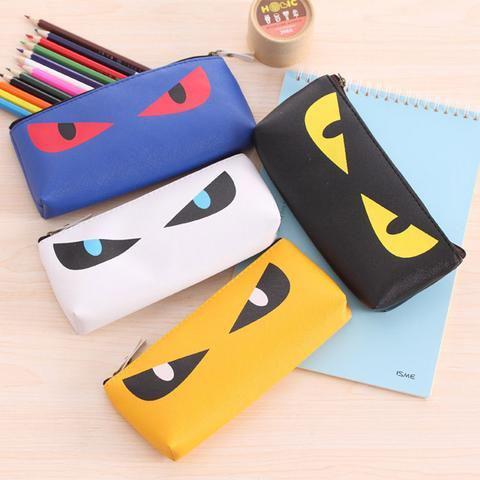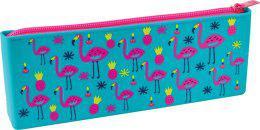The first image is the image on the left, the second image is the image on the right. Examine the images to the left and right. Is the description "there is a pencil pouch with flamingos and flowers on it" accurate? Answer yes or no. Yes. The first image is the image on the left, the second image is the image on the right. For the images shown, is this caption "A pencil case in one image is multicolored with a top zipper, while four zippered cases in the second image are a different style." true? Answer yes or no. Yes. 